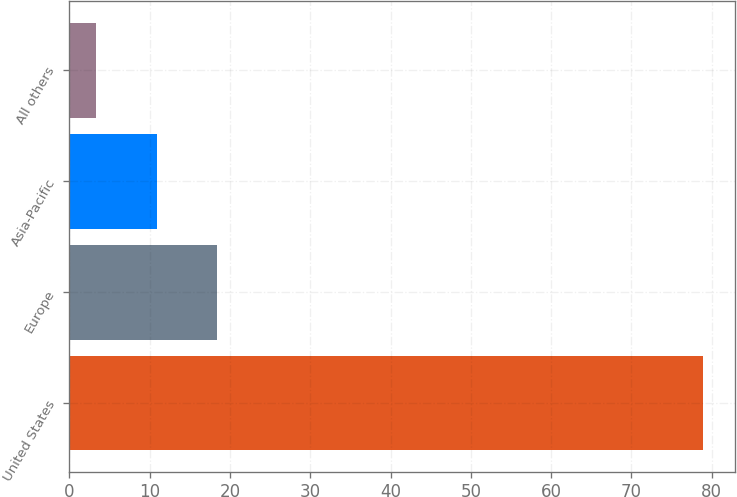Convert chart to OTSL. <chart><loc_0><loc_0><loc_500><loc_500><bar_chart><fcel>United States<fcel>Europe<fcel>Asia-Pacific<fcel>All others<nl><fcel>78.9<fcel>18.42<fcel>10.86<fcel>3.3<nl></chart> 